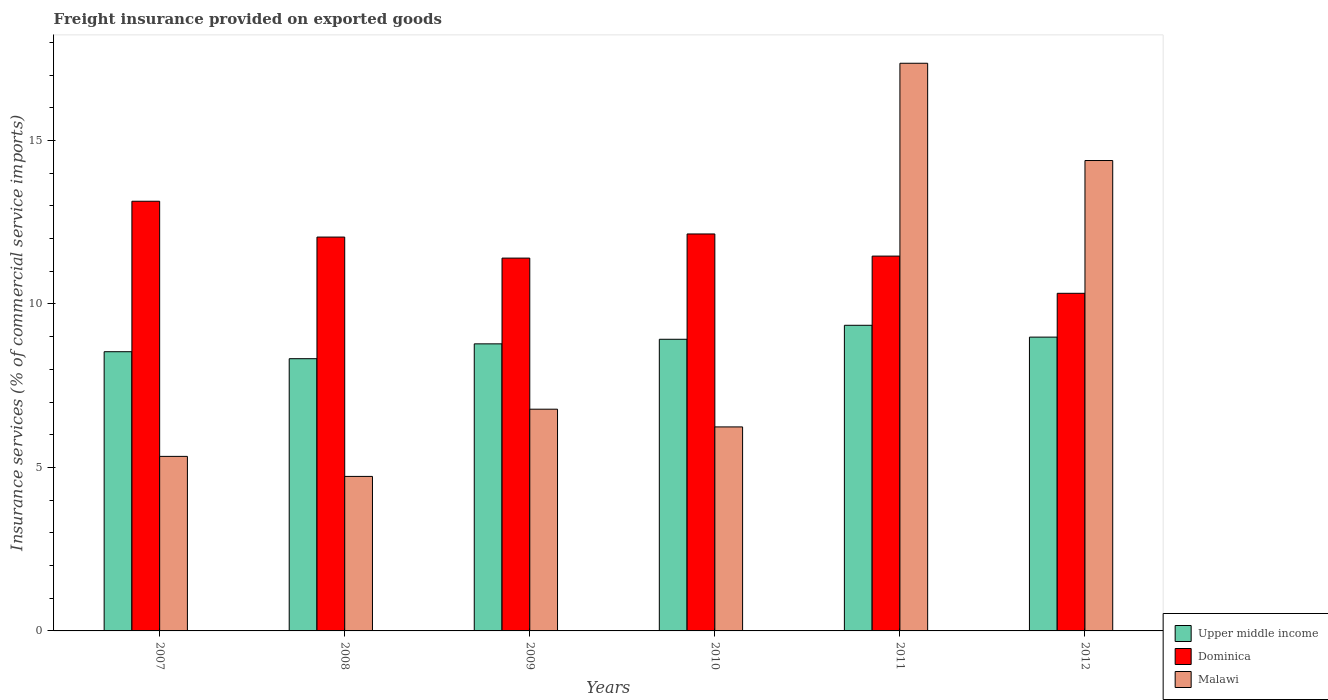How many different coloured bars are there?
Make the answer very short. 3. How many bars are there on the 3rd tick from the right?
Provide a succinct answer. 3. What is the label of the 4th group of bars from the left?
Keep it short and to the point. 2010. What is the freight insurance provided on exported goods in Dominica in 2011?
Offer a terse response. 11.46. Across all years, what is the maximum freight insurance provided on exported goods in Upper middle income?
Keep it short and to the point. 9.35. Across all years, what is the minimum freight insurance provided on exported goods in Dominica?
Offer a terse response. 10.33. In which year was the freight insurance provided on exported goods in Upper middle income maximum?
Provide a succinct answer. 2011. What is the total freight insurance provided on exported goods in Upper middle income in the graph?
Make the answer very short. 52.9. What is the difference between the freight insurance provided on exported goods in Malawi in 2008 and that in 2009?
Your answer should be compact. -2.06. What is the difference between the freight insurance provided on exported goods in Dominica in 2007 and the freight insurance provided on exported goods in Malawi in 2009?
Your answer should be compact. 6.36. What is the average freight insurance provided on exported goods in Dominica per year?
Give a very brief answer. 11.75. In the year 2009, what is the difference between the freight insurance provided on exported goods in Malawi and freight insurance provided on exported goods in Dominica?
Offer a terse response. -4.62. In how many years, is the freight insurance provided on exported goods in Upper middle income greater than 1 %?
Give a very brief answer. 6. What is the ratio of the freight insurance provided on exported goods in Dominica in 2007 to that in 2012?
Your answer should be very brief. 1.27. What is the difference between the highest and the second highest freight insurance provided on exported goods in Malawi?
Offer a very short reply. 2.98. What is the difference between the highest and the lowest freight insurance provided on exported goods in Upper middle income?
Keep it short and to the point. 1.02. In how many years, is the freight insurance provided on exported goods in Upper middle income greater than the average freight insurance provided on exported goods in Upper middle income taken over all years?
Offer a terse response. 3. Is the sum of the freight insurance provided on exported goods in Malawi in 2008 and 2009 greater than the maximum freight insurance provided on exported goods in Upper middle income across all years?
Provide a short and direct response. Yes. What does the 1st bar from the left in 2010 represents?
Provide a short and direct response. Upper middle income. What does the 1st bar from the right in 2007 represents?
Ensure brevity in your answer.  Malawi. Is it the case that in every year, the sum of the freight insurance provided on exported goods in Upper middle income and freight insurance provided on exported goods in Dominica is greater than the freight insurance provided on exported goods in Malawi?
Keep it short and to the point. Yes. How many bars are there?
Your answer should be very brief. 18. How many years are there in the graph?
Provide a short and direct response. 6. Does the graph contain any zero values?
Your response must be concise. No. Where does the legend appear in the graph?
Keep it short and to the point. Bottom right. How many legend labels are there?
Make the answer very short. 3. What is the title of the graph?
Make the answer very short. Freight insurance provided on exported goods. Does "Belgium" appear as one of the legend labels in the graph?
Keep it short and to the point. No. What is the label or title of the X-axis?
Offer a terse response. Years. What is the label or title of the Y-axis?
Provide a short and direct response. Insurance services (% of commercial service imports). What is the Insurance services (% of commercial service imports) in Upper middle income in 2007?
Ensure brevity in your answer.  8.54. What is the Insurance services (% of commercial service imports) in Dominica in 2007?
Provide a succinct answer. 13.14. What is the Insurance services (% of commercial service imports) of Malawi in 2007?
Your response must be concise. 5.34. What is the Insurance services (% of commercial service imports) of Upper middle income in 2008?
Make the answer very short. 8.33. What is the Insurance services (% of commercial service imports) in Dominica in 2008?
Ensure brevity in your answer.  12.05. What is the Insurance services (% of commercial service imports) of Malawi in 2008?
Offer a very short reply. 4.73. What is the Insurance services (% of commercial service imports) of Upper middle income in 2009?
Make the answer very short. 8.78. What is the Insurance services (% of commercial service imports) in Dominica in 2009?
Keep it short and to the point. 11.4. What is the Insurance services (% of commercial service imports) in Malawi in 2009?
Your response must be concise. 6.78. What is the Insurance services (% of commercial service imports) in Upper middle income in 2010?
Ensure brevity in your answer.  8.92. What is the Insurance services (% of commercial service imports) in Dominica in 2010?
Your answer should be very brief. 12.14. What is the Insurance services (% of commercial service imports) of Malawi in 2010?
Ensure brevity in your answer.  6.24. What is the Insurance services (% of commercial service imports) in Upper middle income in 2011?
Your answer should be very brief. 9.35. What is the Insurance services (% of commercial service imports) in Dominica in 2011?
Provide a short and direct response. 11.46. What is the Insurance services (% of commercial service imports) of Malawi in 2011?
Your response must be concise. 17.36. What is the Insurance services (% of commercial service imports) of Upper middle income in 2012?
Your answer should be compact. 8.99. What is the Insurance services (% of commercial service imports) in Dominica in 2012?
Make the answer very short. 10.33. What is the Insurance services (% of commercial service imports) in Malawi in 2012?
Provide a succinct answer. 14.39. Across all years, what is the maximum Insurance services (% of commercial service imports) in Upper middle income?
Give a very brief answer. 9.35. Across all years, what is the maximum Insurance services (% of commercial service imports) in Dominica?
Your answer should be compact. 13.14. Across all years, what is the maximum Insurance services (% of commercial service imports) in Malawi?
Your answer should be compact. 17.36. Across all years, what is the minimum Insurance services (% of commercial service imports) in Upper middle income?
Provide a short and direct response. 8.33. Across all years, what is the minimum Insurance services (% of commercial service imports) of Dominica?
Your answer should be very brief. 10.33. Across all years, what is the minimum Insurance services (% of commercial service imports) of Malawi?
Ensure brevity in your answer.  4.73. What is the total Insurance services (% of commercial service imports) in Upper middle income in the graph?
Your answer should be very brief. 52.9. What is the total Insurance services (% of commercial service imports) of Dominica in the graph?
Keep it short and to the point. 70.53. What is the total Insurance services (% of commercial service imports) in Malawi in the graph?
Provide a succinct answer. 54.84. What is the difference between the Insurance services (% of commercial service imports) of Upper middle income in 2007 and that in 2008?
Keep it short and to the point. 0.21. What is the difference between the Insurance services (% of commercial service imports) in Dominica in 2007 and that in 2008?
Give a very brief answer. 1.1. What is the difference between the Insurance services (% of commercial service imports) of Malawi in 2007 and that in 2008?
Your response must be concise. 0.61. What is the difference between the Insurance services (% of commercial service imports) in Upper middle income in 2007 and that in 2009?
Ensure brevity in your answer.  -0.24. What is the difference between the Insurance services (% of commercial service imports) of Dominica in 2007 and that in 2009?
Your answer should be compact. 1.74. What is the difference between the Insurance services (% of commercial service imports) of Malawi in 2007 and that in 2009?
Your answer should be very brief. -1.44. What is the difference between the Insurance services (% of commercial service imports) of Upper middle income in 2007 and that in 2010?
Give a very brief answer. -0.38. What is the difference between the Insurance services (% of commercial service imports) of Dominica in 2007 and that in 2010?
Your answer should be very brief. 1. What is the difference between the Insurance services (% of commercial service imports) of Malawi in 2007 and that in 2010?
Your response must be concise. -0.9. What is the difference between the Insurance services (% of commercial service imports) in Upper middle income in 2007 and that in 2011?
Provide a succinct answer. -0.81. What is the difference between the Insurance services (% of commercial service imports) in Dominica in 2007 and that in 2011?
Ensure brevity in your answer.  1.68. What is the difference between the Insurance services (% of commercial service imports) in Malawi in 2007 and that in 2011?
Offer a very short reply. -12.02. What is the difference between the Insurance services (% of commercial service imports) in Upper middle income in 2007 and that in 2012?
Offer a very short reply. -0.45. What is the difference between the Insurance services (% of commercial service imports) in Dominica in 2007 and that in 2012?
Give a very brief answer. 2.82. What is the difference between the Insurance services (% of commercial service imports) of Malawi in 2007 and that in 2012?
Ensure brevity in your answer.  -9.05. What is the difference between the Insurance services (% of commercial service imports) of Upper middle income in 2008 and that in 2009?
Your response must be concise. -0.45. What is the difference between the Insurance services (% of commercial service imports) of Dominica in 2008 and that in 2009?
Provide a succinct answer. 0.64. What is the difference between the Insurance services (% of commercial service imports) in Malawi in 2008 and that in 2009?
Make the answer very short. -2.06. What is the difference between the Insurance services (% of commercial service imports) in Upper middle income in 2008 and that in 2010?
Provide a short and direct response. -0.59. What is the difference between the Insurance services (% of commercial service imports) in Dominica in 2008 and that in 2010?
Provide a succinct answer. -0.1. What is the difference between the Insurance services (% of commercial service imports) in Malawi in 2008 and that in 2010?
Ensure brevity in your answer.  -1.51. What is the difference between the Insurance services (% of commercial service imports) in Upper middle income in 2008 and that in 2011?
Make the answer very short. -1.02. What is the difference between the Insurance services (% of commercial service imports) in Dominica in 2008 and that in 2011?
Offer a very short reply. 0.58. What is the difference between the Insurance services (% of commercial service imports) of Malawi in 2008 and that in 2011?
Your response must be concise. -12.64. What is the difference between the Insurance services (% of commercial service imports) of Upper middle income in 2008 and that in 2012?
Provide a short and direct response. -0.66. What is the difference between the Insurance services (% of commercial service imports) in Dominica in 2008 and that in 2012?
Make the answer very short. 1.72. What is the difference between the Insurance services (% of commercial service imports) of Malawi in 2008 and that in 2012?
Your answer should be very brief. -9.66. What is the difference between the Insurance services (% of commercial service imports) in Upper middle income in 2009 and that in 2010?
Keep it short and to the point. -0.14. What is the difference between the Insurance services (% of commercial service imports) of Dominica in 2009 and that in 2010?
Offer a terse response. -0.74. What is the difference between the Insurance services (% of commercial service imports) in Malawi in 2009 and that in 2010?
Offer a very short reply. 0.54. What is the difference between the Insurance services (% of commercial service imports) in Upper middle income in 2009 and that in 2011?
Your answer should be compact. -0.57. What is the difference between the Insurance services (% of commercial service imports) of Dominica in 2009 and that in 2011?
Offer a terse response. -0.06. What is the difference between the Insurance services (% of commercial service imports) in Malawi in 2009 and that in 2011?
Offer a terse response. -10.58. What is the difference between the Insurance services (% of commercial service imports) in Upper middle income in 2009 and that in 2012?
Your answer should be compact. -0.21. What is the difference between the Insurance services (% of commercial service imports) in Dominica in 2009 and that in 2012?
Make the answer very short. 1.08. What is the difference between the Insurance services (% of commercial service imports) of Malawi in 2009 and that in 2012?
Ensure brevity in your answer.  -7.61. What is the difference between the Insurance services (% of commercial service imports) in Upper middle income in 2010 and that in 2011?
Make the answer very short. -0.43. What is the difference between the Insurance services (% of commercial service imports) in Dominica in 2010 and that in 2011?
Provide a succinct answer. 0.68. What is the difference between the Insurance services (% of commercial service imports) in Malawi in 2010 and that in 2011?
Keep it short and to the point. -11.12. What is the difference between the Insurance services (% of commercial service imports) of Upper middle income in 2010 and that in 2012?
Provide a short and direct response. -0.07. What is the difference between the Insurance services (% of commercial service imports) in Dominica in 2010 and that in 2012?
Offer a terse response. 1.82. What is the difference between the Insurance services (% of commercial service imports) of Malawi in 2010 and that in 2012?
Your response must be concise. -8.15. What is the difference between the Insurance services (% of commercial service imports) in Upper middle income in 2011 and that in 2012?
Offer a very short reply. 0.36. What is the difference between the Insurance services (% of commercial service imports) in Dominica in 2011 and that in 2012?
Ensure brevity in your answer.  1.14. What is the difference between the Insurance services (% of commercial service imports) in Malawi in 2011 and that in 2012?
Make the answer very short. 2.98. What is the difference between the Insurance services (% of commercial service imports) of Upper middle income in 2007 and the Insurance services (% of commercial service imports) of Dominica in 2008?
Your answer should be compact. -3.51. What is the difference between the Insurance services (% of commercial service imports) in Upper middle income in 2007 and the Insurance services (% of commercial service imports) in Malawi in 2008?
Give a very brief answer. 3.81. What is the difference between the Insurance services (% of commercial service imports) of Dominica in 2007 and the Insurance services (% of commercial service imports) of Malawi in 2008?
Keep it short and to the point. 8.42. What is the difference between the Insurance services (% of commercial service imports) in Upper middle income in 2007 and the Insurance services (% of commercial service imports) in Dominica in 2009?
Ensure brevity in your answer.  -2.86. What is the difference between the Insurance services (% of commercial service imports) in Upper middle income in 2007 and the Insurance services (% of commercial service imports) in Malawi in 2009?
Offer a very short reply. 1.76. What is the difference between the Insurance services (% of commercial service imports) in Dominica in 2007 and the Insurance services (% of commercial service imports) in Malawi in 2009?
Keep it short and to the point. 6.36. What is the difference between the Insurance services (% of commercial service imports) in Upper middle income in 2007 and the Insurance services (% of commercial service imports) in Dominica in 2010?
Your response must be concise. -3.6. What is the difference between the Insurance services (% of commercial service imports) of Upper middle income in 2007 and the Insurance services (% of commercial service imports) of Malawi in 2010?
Your response must be concise. 2.3. What is the difference between the Insurance services (% of commercial service imports) in Dominica in 2007 and the Insurance services (% of commercial service imports) in Malawi in 2010?
Keep it short and to the point. 6.9. What is the difference between the Insurance services (% of commercial service imports) of Upper middle income in 2007 and the Insurance services (% of commercial service imports) of Dominica in 2011?
Give a very brief answer. -2.92. What is the difference between the Insurance services (% of commercial service imports) of Upper middle income in 2007 and the Insurance services (% of commercial service imports) of Malawi in 2011?
Your answer should be very brief. -8.82. What is the difference between the Insurance services (% of commercial service imports) in Dominica in 2007 and the Insurance services (% of commercial service imports) in Malawi in 2011?
Give a very brief answer. -4.22. What is the difference between the Insurance services (% of commercial service imports) of Upper middle income in 2007 and the Insurance services (% of commercial service imports) of Dominica in 2012?
Your answer should be very brief. -1.79. What is the difference between the Insurance services (% of commercial service imports) of Upper middle income in 2007 and the Insurance services (% of commercial service imports) of Malawi in 2012?
Give a very brief answer. -5.85. What is the difference between the Insurance services (% of commercial service imports) of Dominica in 2007 and the Insurance services (% of commercial service imports) of Malawi in 2012?
Your response must be concise. -1.25. What is the difference between the Insurance services (% of commercial service imports) of Upper middle income in 2008 and the Insurance services (% of commercial service imports) of Dominica in 2009?
Offer a terse response. -3.08. What is the difference between the Insurance services (% of commercial service imports) of Upper middle income in 2008 and the Insurance services (% of commercial service imports) of Malawi in 2009?
Your answer should be compact. 1.54. What is the difference between the Insurance services (% of commercial service imports) in Dominica in 2008 and the Insurance services (% of commercial service imports) in Malawi in 2009?
Provide a succinct answer. 5.26. What is the difference between the Insurance services (% of commercial service imports) of Upper middle income in 2008 and the Insurance services (% of commercial service imports) of Dominica in 2010?
Provide a short and direct response. -3.82. What is the difference between the Insurance services (% of commercial service imports) in Upper middle income in 2008 and the Insurance services (% of commercial service imports) in Malawi in 2010?
Make the answer very short. 2.09. What is the difference between the Insurance services (% of commercial service imports) of Dominica in 2008 and the Insurance services (% of commercial service imports) of Malawi in 2010?
Make the answer very short. 5.81. What is the difference between the Insurance services (% of commercial service imports) of Upper middle income in 2008 and the Insurance services (% of commercial service imports) of Dominica in 2011?
Offer a very short reply. -3.14. What is the difference between the Insurance services (% of commercial service imports) of Upper middle income in 2008 and the Insurance services (% of commercial service imports) of Malawi in 2011?
Keep it short and to the point. -9.04. What is the difference between the Insurance services (% of commercial service imports) of Dominica in 2008 and the Insurance services (% of commercial service imports) of Malawi in 2011?
Provide a succinct answer. -5.32. What is the difference between the Insurance services (% of commercial service imports) in Upper middle income in 2008 and the Insurance services (% of commercial service imports) in Dominica in 2012?
Make the answer very short. -2. What is the difference between the Insurance services (% of commercial service imports) in Upper middle income in 2008 and the Insurance services (% of commercial service imports) in Malawi in 2012?
Give a very brief answer. -6.06. What is the difference between the Insurance services (% of commercial service imports) of Dominica in 2008 and the Insurance services (% of commercial service imports) of Malawi in 2012?
Your answer should be compact. -2.34. What is the difference between the Insurance services (% of commercial service imports) of Upper middle income in 2009 and the Insurance services (% of commercial service imports) of Dominica in 2010?
Your answer should be very brief. -3.36. What is the difference between the Insurance services (% of commercial service imports) in Upper middle income in 2009 and the Insurance services (% of commercial service imports) in Malawi in 2010?
Provide a succinct answer. 2.54. What is the difference between the Insurance services (% of commercial service imports) in Dominica in 2009 and the Insurance services (% of commercial service imports) in Malawi in 2010?
Your response must be concise. 5.16. What is the difference between the Insurance services (% of commercial service imports) in Upper middle income in 2009 and the Insurance services (% of commercial service imports) in Dominica in 2011?
Provide a short and direct response. -2.68. What is the difference between the Insurance services (% of commercial service imports) in Upper middle income in 2009 and the Insurance services (% of commercial service imports) in Malawi in 2011?
Provide a succinct answer. -8.58. What is the difference between the Insurance services (% of commercial service imports) in Dominica in 2009 and the Insurance services (% of commercial service imports) in Malawi in 2011?
Your answer should be very brief. -5.96. What is the difference between the Insurance services (% of commercial service imports) of Upper middle income in 2009 and the Insurance services (% of commercial service imports) of Dominica in 2012?
Ensure brevity in your answer.  -1.55. What is the difference between the Insurance services (% of commercial service imports) in Upper middle income in 2009 and the Insurance services (% of commercial service imports) in Malawi in 2012?
Give a very brief answer. -5.61. What is the difference between the Insurance services (% of commercial service imports) of Dominica in 2009 and the Insurance services (% of commercial service imports) of Malawi in 2012?
Your response must be concise. -2.98. What is the difference between the Insurance services (% of commercial service imports) of Upper middle income in 2010 and the Insurance services (% of commercial service imports) of Dominica in 2011?
Ensure brevity in your answer.  -2.54. What is the difference between the Insurance services (% of commercial service imports) in Upper middle income in 2010 and the Insurance services (% of commercial service imports) in Malawi in 2011?
Offer a very short reply. -8.44. What is the difference between the Insurance services (% of commercial service imports) in Dominica in 2010 and the Insurance services (% of commercial service imports) in Malawi in 2011?
Provide a succinct answer. -5.22. What is the difference between the Insurance services (% of commercial service imports) in Upper middle income in 2010 and the Insurance services (% of commercial service imports) in Dominica in 2012?
Your answer should be very brief. -1.41. What is the difference between the Insurance services (% of commercial service imports) of Upper middle income in 2010 and the Insurance services (% of commercial service imports) of Malawi in 2012?
Your answer should be very brief. -5.47. What is the difference between the Insurance services (% of commercial service imports) in Dominica in 2010 and the Insurance services (% of commercial service imports) in Malawi in 2012?
Offer a terse response. -2.25. What is the difference between the Insurance services (% of commercial service imports) of Upper middle income in 2011 and the Insurance services (% of commercial service imports) of Dominica in 2012?
Provide a short and direct response. -0.98. What is the difference between the Insurance services (% of commercial service imports) of Upper middle income in 2011 and the Insurance services (% of commercial service imports) of Malawi in 2012?
Provide a succinct answer. -5.04. What is the difference between the Insurance services (% of commercial service imports) in Dominica in 2011 and the Insurance services (% of commercial service imports) in Malawi in 2012?
Offer a terse response. -2.92. What is the average Insurance services (% of commercial service imports) of Upper middle income per year?
Ensure brevity in your answer.  8.82. What is the average Insurance services (% of commercial service imports) in Dominica per year?
Give a very brief answer. 11.75. What is the average Insurance services (% of commercial service imports) in Malawi per year?
Your response must be concise. 9.14. In the year 2007, what is the difference between the Insurance services (% of commercial service imports) of Upper middle income and Insurance services (% of commercial service imports) of Dominica?
Provide a short and direct response. -4.6. In the year 2007, what is the difference between the Insurance services (% of commercial service imports) of Upper middle income and Insurance services (% of commercial service imports) of Malawi?
Ensure brevity in your answer.  3.2. In the year 2007, what is the difference between the Insurance services (% of commercial service imports) of Dominica and Insurance services (% of commercial service imports) of Malawi?
Offer a very short reply. 7.8. In the year 2008, what is the difference between the Insurance services (% of commercial service imports) in Upper middle income and Insurance services (% of commercial service imports) in Dominica?
Keep it short and to the point. -3.72. In the year 2008, what is the difference between the Insurance services (% of commercial service imports) in Upper middle income and Insurance services (% of commercial service imports) in Malawi?
Provide a succinct answer. 3.6. In the year 2008, what is the difference between the Insurance services (% of commercial service imports) of Dominica and Insurance services (% of commercial service imports) of Malawi?
Offer a very short reply. 7.32. In the year 2009, what is the difference between the Insurance services (% of commercial service imports) of Upper middle income and Insurance services (% of commercial service imports) of Dominica?
Ensure brevity in your answer.  -2.62. In the year 2009, what is the difference between the Insurance services (% of commercial service imports) in Upper middle income and Insurance services (% of commercial service imports) in Malawi?
Keep it short and to the point. 2. In the year 2009, what is the difference between the Insurance services (% of commercial service imports) of Dominica and Insurance services (% of commercial service imports) of Malawi?
Provide a succinct answer. 4.62. In the year 2010, what is the difference between the Insurance services (% of commercial service imports) of Upper middle income and Insurance services (% of commercial service imports) of Dominica?
Your response must be concise. -3.22. In the year 2010, what is the difference between the Insurance services (% of commercial service imports) of Upper middle income and Insurance services (% of commercial service imports) of Malawi?
Make the answer very short. 2.68. In the year 2010, what is the difference between the Insurance services (% of commercial service imports) in Dominica and Insurance services (% of commercial service imports) in Malawi?
Provide a succinct answer. 5.9. In the year 2011, what is the difference between the Insurance services (% of commercial service imports) in Upper middle income and Insurance services (% of commercial service imports) in Dominica?
Ensure brevity in your answer.  -2.12. In the year 2011, what is the difference between the Insurance services (% of commercial service imports) in Upper middle income and Insurance services (% of commercial service imports) in Malawi?
Keep it short and to the point. -8.01. In the year 2011, what is the difference between the Insurance services (% of commercial service imports) of Dominica and Insurance services (% of commercial service imports) of Malawi?
Keep it short and to the point. -5.9. In the year 2012, what is the difference between the Insurance services (% of commercial service imports) in Upper middle income and Insurance services (% of commercial service imports) in Dominica?
Make the answer very short. -1.34. In the year 2012, what is the difference between the Insurance services (% of commercial service imports) in Upper middle income and Insurance services (% of commercial service imports) in Malawi?
Keep it short and to the point. -5.4. In the year 2012, what is the difference between the Insurance services (% of commercial service imports) in Dominica and Insurance services (% of commercial service imports) in Malawi?
Offer a very short reply. -4.06. What is the ratio of the Insurance services (% of commercial service imports) of Upper middle income in 2007 to that in 2008?
Keep it short and to the point. 1.03. What is the ratio of the Insurance services (% of commercial service imports) of Dominica in 2007 to that in 2008?
Ensure brevity in your answer.  1.09. What is the ratio of the Insurance services (% of commercial service imports) in Malawi in 2007 to that in 2008?
Your answer should be compact. 1.13. What is the ratio of the Insurance services (% of commercial service imports) in Upper middle income in 2007 to that in 2009?
Make the answer very short. 0.97. What is the ratio of the Insurance services (% of commercial service imports) of Dominica in 2007 to that in 2009?
Ensure brevity in your answer.  1.15. What is the ratio of the Insurance services (% of commercial service imports) in Malawi in 2007 to that in 2009?
Your answer should be very brief. 0.79. What is the ratio of the Insurance services (% of commercial service imports) of Upper middle income in 2007 to that in 2010?
Your answer should be compact. 0.96. What is the ratio of the Insurance services (% of commercial service imports) of Dominica in 2007 to that in 2010?
Ensure brevity in your answer.  1.08. What is the ratio of the Insurance services (% of commercial service imports) of Malawi in 2007 to that in 2010?
Make the answer very short. 0.86. What is the ratio of the Insurance services (% of commercial service imports) in Upper middle income in 2007 to that in 2011?
Give a very brief answer. 0.91. What is the ratio of the Insurance services (% of commercial service imports) in Dominica in 2007 to that in 2011?
Make the answer very short. 1.15. What is the ratio of the Insurance services (% of commercial service imports) in Malawi in 2007 to that in 2011?
Provide a short and direct response. 0.31. What is the ratio of the Insurance services (% of commercial service imports) in Upper middle income in 2007 to that in 2012?
Ensure brevity in your answer.  0.95. What is the ratio of the Insurance services (% of commercial service imports) in Dominica in 2007 to that in 2012?
Keep it short and to the point. 1.27. What is the ratio of the Insurance services (% of commercial service imports) of Malawi in 2007 to that in 2012?
Your answer should be very brief. 0.37. What is the ratio of the Insurance services (% of commercial service imports) of Upper middle income in 2008 to that in 2009?
Offer a terse response. 0.95. What is the ratio of the Insurance services (% of commercial service imports) of Dominica in 2008 to that in 2009?
Provide a short and direct response. 1.06. What is the ratio of the Insurance services (% of commercial service imports) in Malawi in 2008 to that in 2009?
Provide a short and direct response. 0.7. What is the ratio of the Insurance services (% of commercial service imports) in Upper middle income in 2008 to that in 2010?
Your answer should be compact. 0.93. What is the ratio of the Insurance services (% of commercial service imports) in Malawi in 2008 to that in 2010?
Keep it short and to the point. 0.76. What is the ratio of the Insurance services (% of commercial service imports) in Upper middle income in 2008 to that in 2011?
Ensure brevity in your answer.  0.89. What is the ratio of the Insurance services (% of commercial service imports) of Dominica in 2008 to that in 2011?
Offer a very short reply. 1.05. What is the ratio of the Insurance services (% of commercial service imports) of Malawi in 2008 to that in 2011?
Your answer should be compact. 0.27. What is the ratio of the Insurance services (% of commercial service imports) of Upper middle income in 2008 to that in 2012?
Give a very brief answer. 0.93. What is the ratio of the Insurance services (% of commercial service imports) of Dominica in 2008 to that in 2012?
Keep it short and to the point. 1.17. What is the ratio of the Insurance services (% of commercial service imports) in Malawi in 2008 to that in 2012?
Your answer should be compact. 0.33. What is the ratio of the Insurance services (% of commercial service imports) of Upper middle income in 2009 to that in 2010?
Provide a short and direct response. 0.98. What is the ratio of the Insurance services (% of commercial service imports) in Dominica in 2009 to that in 2010?
Offer a terse response. 0.94. What is the ratio of the Insurance services (% of commercial service imports) of Malawi in 2009 to that in 2010?
Your answer should be compact. 1.09. What is the ratio of the Insurance services (% of commercial service imports) of Upper middle income in 2009 to that in 2011?
Your answer should be compact. 0.94. What is the ratio of the Insurance services (% of commercial service imports) of Dominica in 2009 to that in 2011?
Keep it short and to the point. 0.99. What is the ratio of the Insurance services (% of commercial service imports) in Malawi in 2009 to that in 2011?
Your response must be concise. 0.39. What is the ratio of the Insurance services (% of commercial service imports) of Upper middle income in 2009 to that in 2012?
Give a very brief answer. 0.98. What is the ratio of the Insurance services (% of commercial service imports) in Dominica in 2009 to that in 2012?
Provide a short and direct response. 1.1. What is the ratio of the Insurance services (% of commercial service imports) in Malawi in 2009 to that in 2012?
Keep it short and to the point. 0.47. What is the ratio of the Insurance services (% of commercial service imports) of Upper middle income in 2010 to that in 2011?
Your answer should be compact. 0.95. What is the ratio of the Insurance services (% of commercial service imports) of Dominica in 2010 to that in 2011?
Provide a short and direct response. 1.06. What is the ratio of the Insurance services (% of commercial service imports) of Malawi in 2010 to that in 2011?
Your response must be concise. 0.36. What is the ratio of the Insurance services (% of commercial service imports) of Upper middle income in 2010 to that in 2012?
Keep it short and to the point. 0.99. What is the ratio of the Insurance services (% of commercial service imports) of Dominica in 2010 to that in 2012?
Keep it short and to the point. 1.18. What is the ratio of the Insurance services (% of commercial service imports) in Malawi in 2010 to that in 2012?
Give a very brief answer. 0.43. What is the ratio of the Insurance services (% of commercial service imports) in Upper middle income in 2011 to that in 2012?
Offer a terse response. 1.04. What is the ratio of the Insurance services (% of commercial service imports) of Dominica in 2011 to that in 2012?
Your answer should be very brief. 1.11. What is the ratio of the Insurance services (% of commercial service imports) in Malawi in 2011 to that in 2012?
Give a very brief answer. 1.21. What is the difference between the highest and the second highest Insurance services (% of commercial service imports) in Upper middle income?
Offer a very short reply. 0.36. What is the difference between the highest and the second highest Insurance services (% of commercial service imports) in Malawi?
Make the answer very short. 2.98. What is the difference between the highest and the lowest Insurance services (% of commercial service imports) in Upper middle income?
Your answer should be compact. 1.02. What is the difference between the highest and the lowest Insurance services (% of commercial service imports) in Dominica?
Offer a terse response. 2.82. What is the difference between the highest and the lowest Insurance services (% of commercial service imports) in Malawi?
Ensure brevity in your answer.  12.64. 